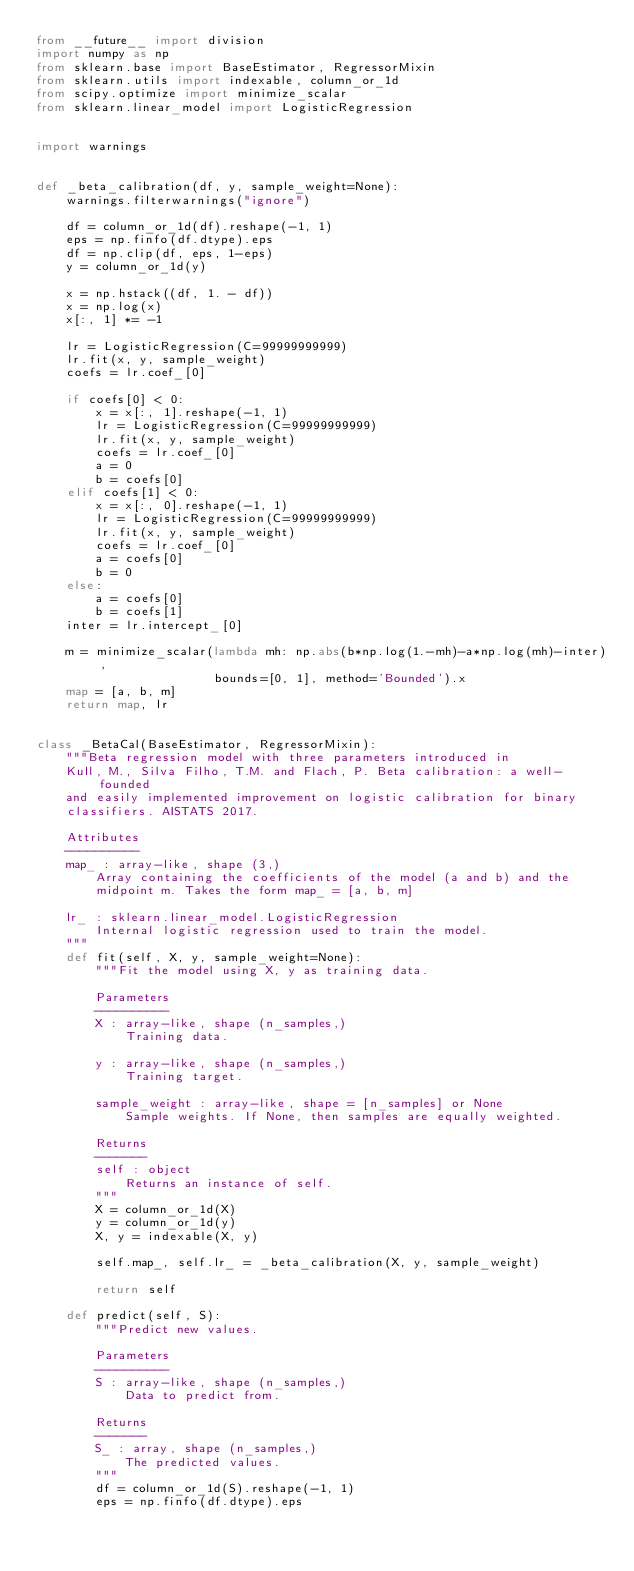Convert code to text. <code><loc_0><loc_0><loc_500><loc_500><_Python_>from __future__ import division
import numpy as np
from sklearn.base import BaseEstimator, RegressorMixin
from sklearn.utils import indexable, column_or_1d
from scipy.optimize import minimize_scalar
from sklearn.linear_model import LogisticRegression


import warnings


def _beta_calibration(df, y, sample_weight=None):
    warnings.filterwarnings("ignore")

    df = column_or_1d(df).reshape(-1, 1)
    eps = np.finfo(df.dtype).eps
    df = np.clip(df, eps, 1-eps)
    y = column_or_1d(y)

    x = np.hstack((df, 1. - df))
    x = np.log(x)
    x[:, 1] *= -1

    lr = LogisticRegression(C=99999999999)
    lr.fit(x, y, sample_weight)
    coefs = lr.coef_[0]

    if coefs[0] < 0:
        x = x[:, 1].reshape(-1, 1)
        lr = LogisticRegression(C=99999999999)
        lr.fit(x, y, sample_weight)
        coefs = lr.coef_[0]
        a = 0
        b = coefs[0]
    elif coefs[1] < 0:
        x = x[:, 0].reshape(-1, 1)
        lr = LogisticRegression(C=99999999999)
        lr.fit(x, y, sample_weight)
        coefs = lr.coef_[0]
        a = coefs[0]
        b = 0
    else:
        a = coefs[0]
        b = coefs[1]
    inter = lr.intercept_[0]

    m = minimize_scalar(lambda mh: np.abs(b*np.log(1.-mh)-a*np.log(mh)-inter),
                        bounds=[0, 1], method='Bounded').x
    map = [a, b, m]
    return map, lr


class _BetaCal(BaseEstimator, RegressorMixin):
    """Beta regression model with three parameters introduced in
    Kull, M., Silva Filho, T.M. and Flach, P. Beta calibration: a well-founded
    and easily implemented improvement on logistic calibration for binary
    classifiers. AISTATS 2017.

    Attributes
    ----------
    map_ : array-like, shape (3,)
        Array containing the coefficients of the model (a and b) and the
        midpoint m. Takes the form map_ = [a, b, m]

    lr_ : sklearn.linear_model.LogisticRegression
        Internal logistic regression used to train the model.
    """
    def fit(self, X, y, sample_weight=None):
        """Fit the model using X, y as training data.

        Parameters
        ----------
        X : array-like, shape (n_samples,)
            Training data.

        y : array-like, shape (n_samples,)
            Training target.

        sample_weight : array-like, shape = [n_samples] or None
            Sample weights. If None, then samples are equally weighted.

        Returns
        -------
        self : object
            Returns an instance of self.
        """
        X = column_or_1d(X)
        y = column_or_1d(y)
        X, y = indexable(X, y)

        self.map_, self.lr_ = _beta_calibration(X, y, sample_weight)

        return self

    def predict(self, S):
        """Predict new values.

        Parameters
        ----------
        S : array-like, shape (n_samples,)
            Data to predict from.

        Returns
        -------
        S_ : array, shape (n_samples,)
            The predicted values.
        """
        df = column_or_1d(S).reshape(-1, 1)
        eps = np.finfo(df.dtype).eps</code> 